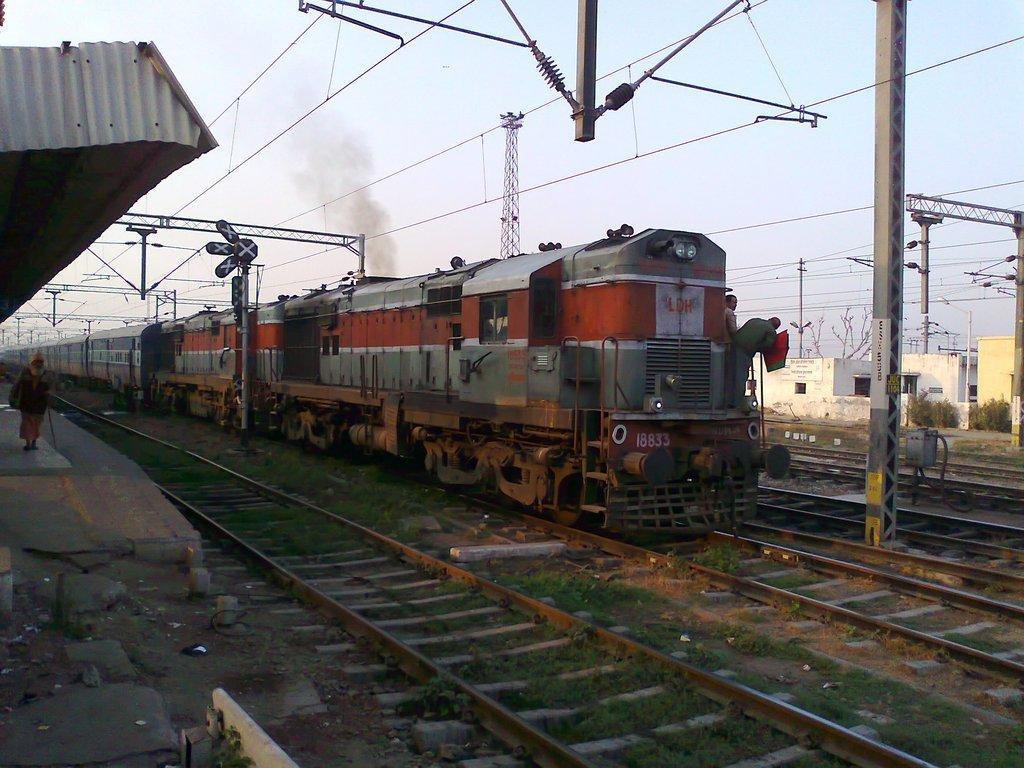Can you describe this image briefly? In this image I can see the train on the track. On both sides of the train I can see the poles. To the left I can see the person standing on the platform. To the right I can see the plants, buildings and trees. In the background I can see the sky. 